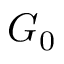<formula> <loc_0><loc_0><loc_500><loc_500>G _ { 0 }</formula> 